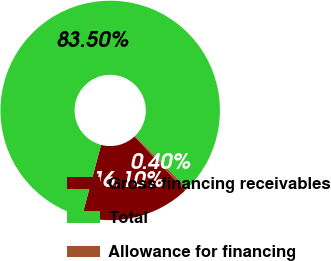Convert chart. <chart><loc_0><loc_0><loc_500><loc_500><pie_chart><fcel>Gross financing receivables<fcel>Total<fcel>Allowance for financing<nl><fcel>16.1%<fcel>83.5%<fcel>0.4%<nl></chart> 